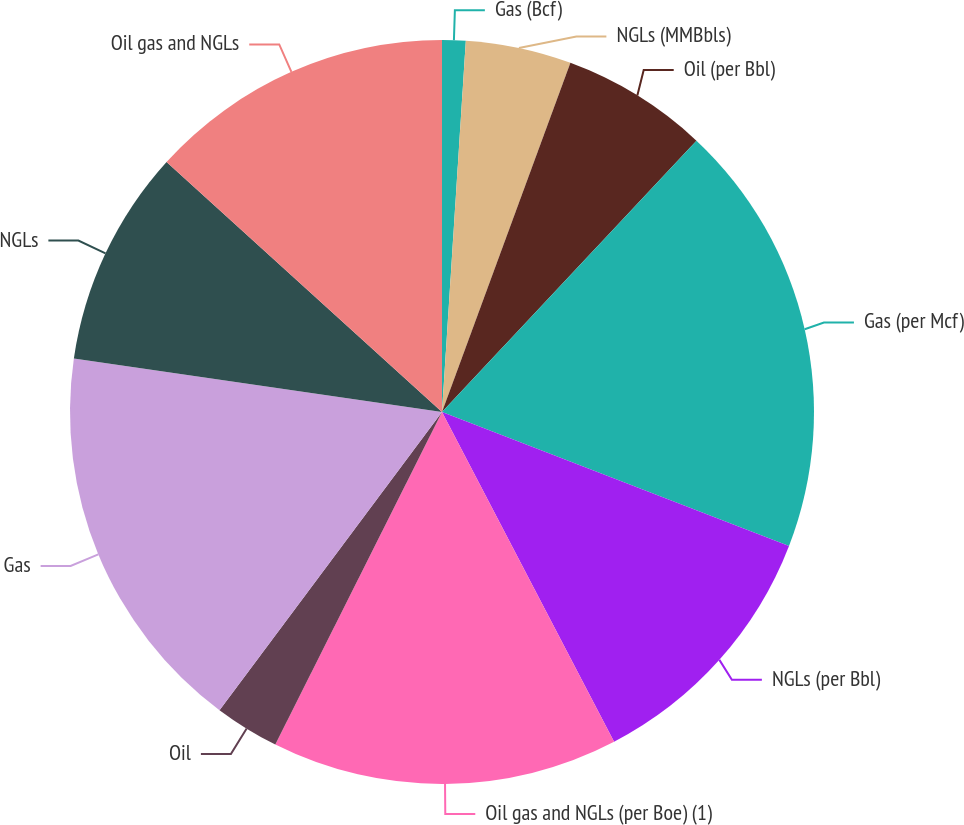Convert chart to OTSL. <chart><loc_0><loc_0><loc_500><loc_500><pie_chart><fcel>Gas (Bcf)<fcel>NGLs (MMBbls)<fcel>Oil (per Bbl)<fcel>Gas (per Mcf)<fcel>NGLs (per Bbl)<fcel>Oil gas and NGLs (per Boe) (1)<fcel>Oil<fcel>Gas<fcel>NGLs<fcel>Oil gas and NGLs<nl><fcel>1.02%<fcel>4.59%<fcel>6.38%<fcel>18.88%<fcel>11.48%<fcel>15.05%<fcel>2.81%<fcel>17.09%<fcel>9.44%<fcel>13.27%<nl></chart> 